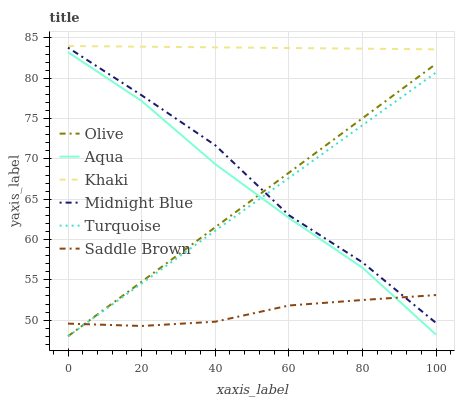Does Midnight Blue have the minimum area under the curve?
Answer yes or no. No. Does Midnight Blue have the maximum area under the curve?
Answer yes or no. No. Is Khaki the smoothest?
Answer yes or no. No. Is Khaki the roughest?
Answer yes or no. No. Does Midnight Blue have the lowest value?
Answer yes or no. No. Does Midnight Blue have the highest value?
Answer yes or no. No. Is Aqua less than Khaki?
Answer yes or no. Yes. Is Khaki greater than Saddle Brown?
Answer yes or no. Yes. Does Aqua intersect Khaki?
Answer yes or no. No. 